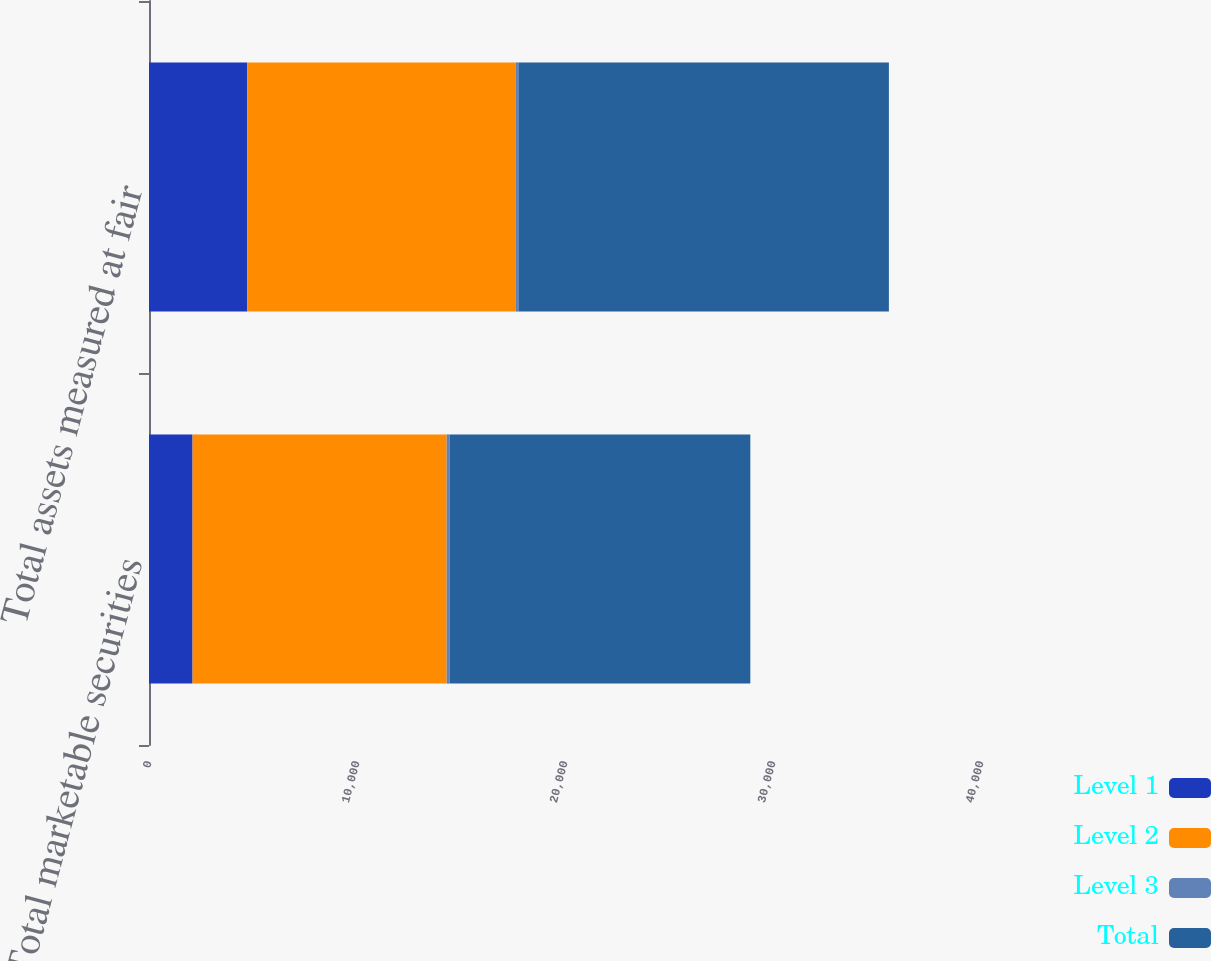Convert chart to OTSL. <chart><loc_0><loc_0><loc_500><loc_500><stacked_bar_chart><ecel><fcel>Total marketable securities<fcel>Total assets measured at fair<nl><fcel>Level 1<fcel>2095<fcel>4728<nl><fcel>Level 2<fcel>12216<fcel>12914<nl><fcel>Level 3<fcel>144<fcel>144<nl><fcel>Total<fcel>14455<fcel>17786<nl></chart> 